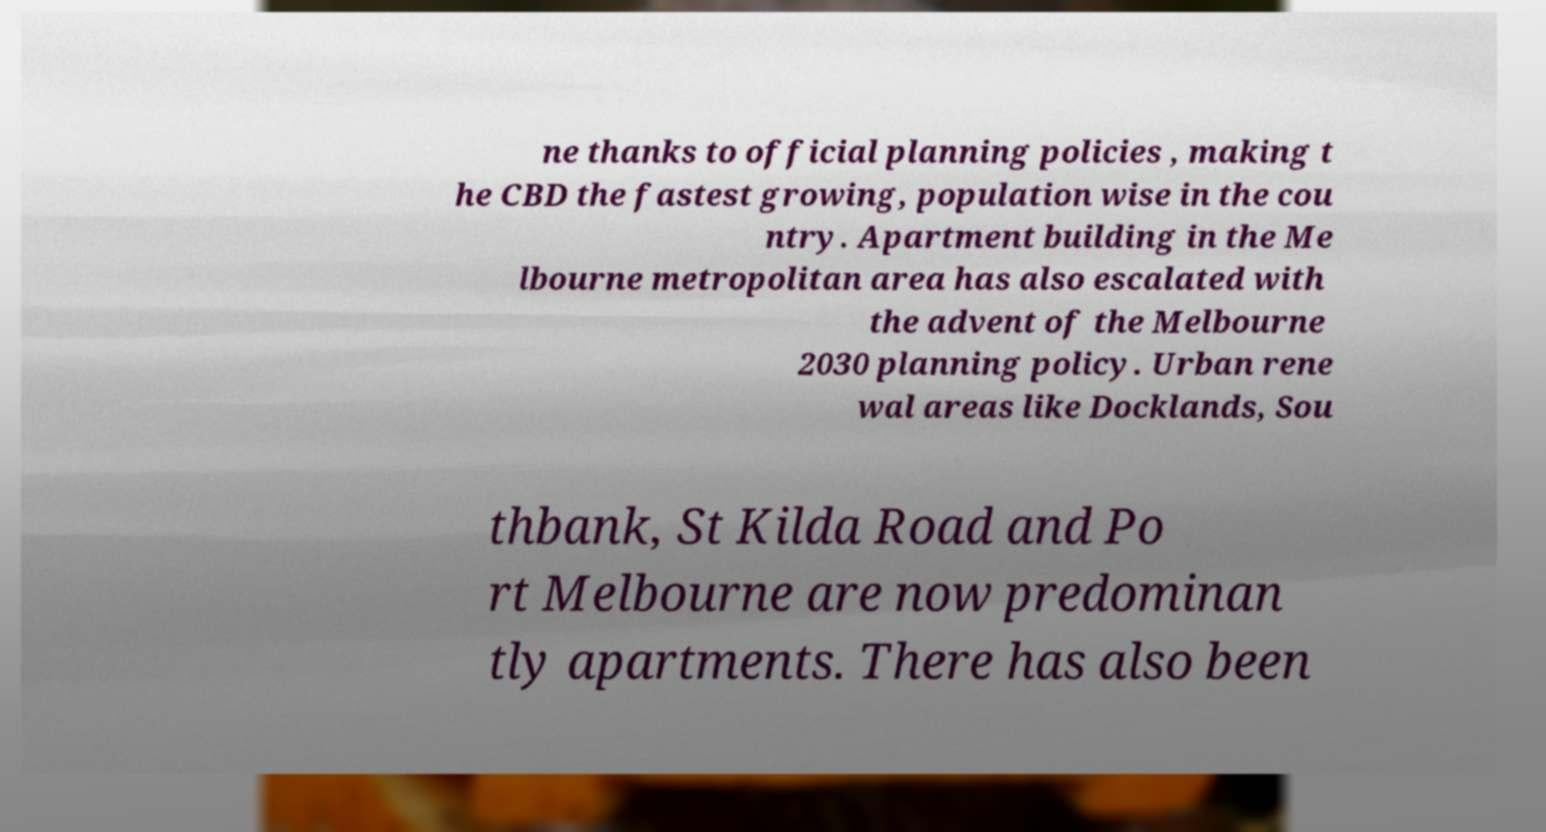Could you assist in decoding the text presented in this image and type it out clearly? ne thanks to official planning policies , making t he CBD the fastest growing, population wise in the cou ntry. Apartment building in the Me lbourne metropolitan area has also escalated with the advent of the Melbourne 2030 planning policy. Urban rene wal areas like Docklands, Sou thbank, St Kilda Road and Po rt Melbourne are now predominan tly apartments. There has also been 